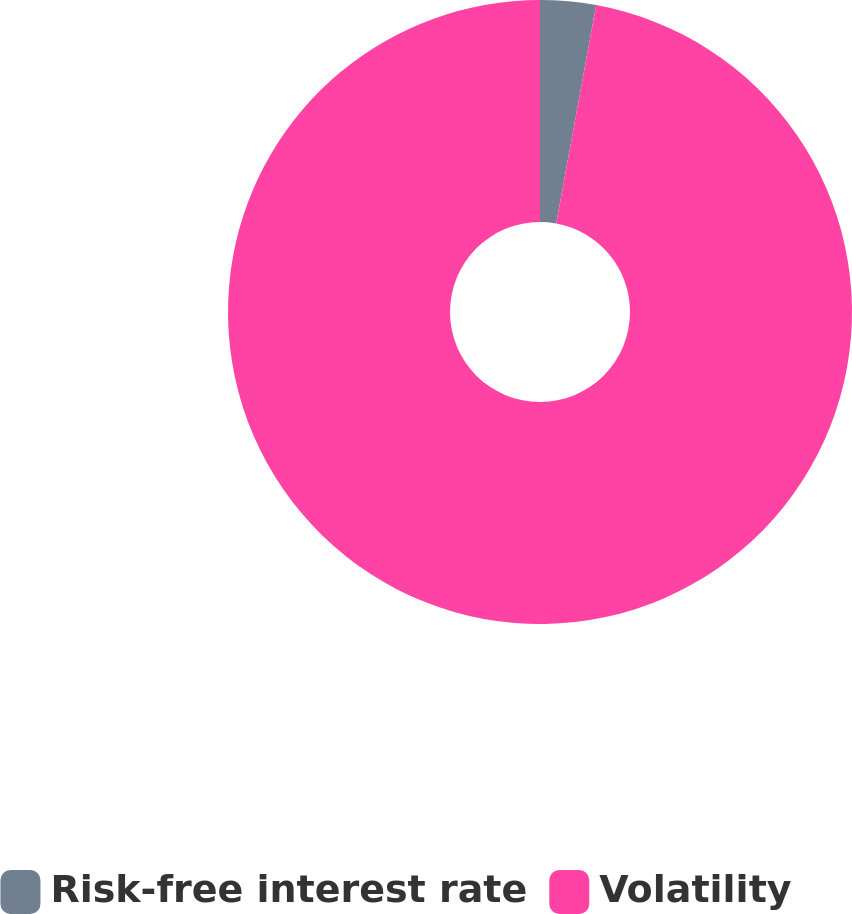Convert chart. <chart><loc_0><loc_0><loc_500><loc_500><pie_chart><fcel>Risk-free interest rate<fcel>Volatility<nl><fcel>2.88%<fcel>97.12%<nl></chart> 